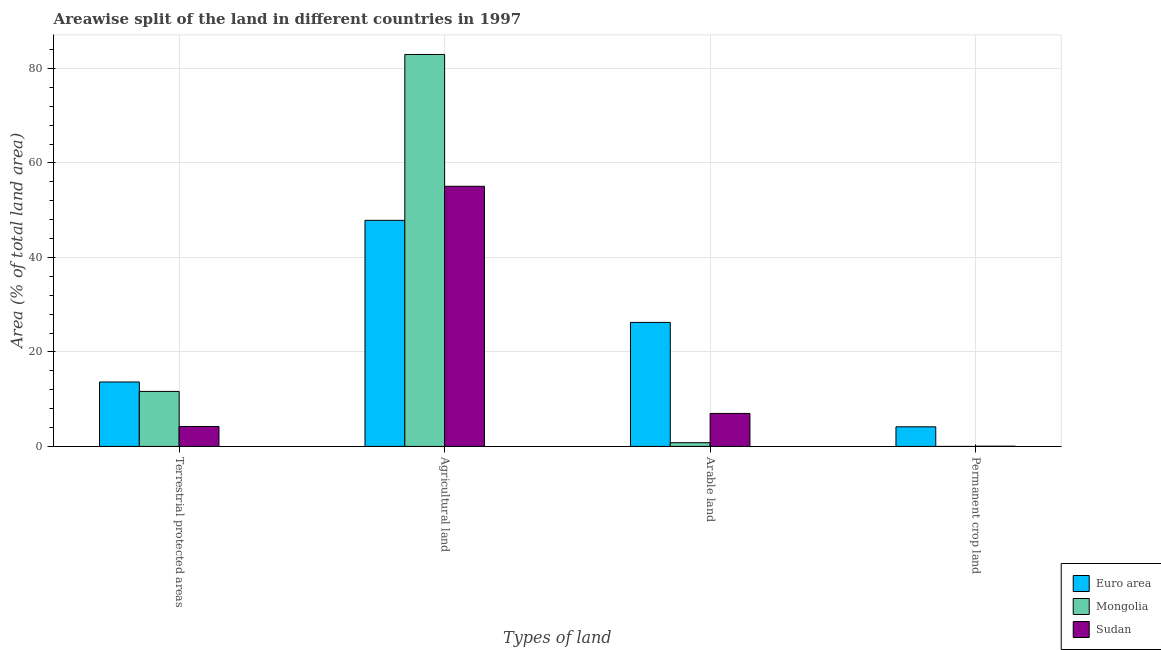How many groups of bars are there?
Make the answer very short. 4. Are the number of bars on each tick of the X-axis equal?
Your answer should be compact. Yes. How many bars are there on the 1st tick from the left?
Give a very brief answer. 3. How many bars are there on the 4th tick from the right?
Your answer should be very brief. 3. What is the label of the 3rd group of bars from the left?
Keep it short and to the point. Arable land. What is the percentage of area under arable land in Sudan?
Provide a short and direct response. 6.99. Across all countries, what is the maximum percentage of area under permanent crop land?
Provide a succinct answer. 4.15. Across all countries, what is the minimum percentage of land under terrestrial protection?
Ensure brevity in your answer.  4.22. In which country was the percentage of land under terrestrial protection minimum?
Provide a succinct answer. Sudan. What is the total percentage of area under permanent crop land in the graph?
Ensure brevity in your answer.  4.2. What is the difference between the percentage of area under agricultural land in Sudan and that in Mongolia?
Provide a succinct answer. -27.9. What is the difference between the percentage of area under agricultural land in Mongolia and the percentage of area under permanent crop land in Sudan?
Ensure brevity in your answer.  82.92. What is the average percentage of area under agricultural land per country?
Make the answer very short. 61.96. What is the difference between the percentage of area under arable land and percentage of area under permanent crop land in Sudan?
Give a very brief answer. 6.94. What is the ratio of the percentage of area under arable land in Sudan to that in Euro area?
Offer a terse response. 0.27. Is the percentage of area under arable land in Sudan less than that in Euro area?
Make the answer very short. Yes. What is the difference between the highest and the second highest percentage of area under permanent crop land?
Ensure brevity in your answer.  4.1. What is the difference between the highest and the lowest percentage of land under terrestrial protection?
Your answer should be compact. 9.42. Is it the case that in every country, the sum of the percentage of area under permanent crop land and percentage of area under agricultural land is greater than the sum of percentage of area under arable land and percentage of land under terrestrial protection?
Provide a succinct answer. No. What does the 3rd bar from the left in Arable land represents?
Offer a terse response. Sudan. What does the 1st bar from the right in Permanent crop land represents?
Offer a terse response. Sudan. How many bars are there?
Provide a succinct answer. 12. Are all the bars in the graph horizontal?
Ensure brevity in your answer.  No. Where does the legend appear in the graph?
Your answer should be compact. Bottom right. What is the title of the graph?
Your answer should be compact. Areawise split of the land in different countries in 1997. What is the label or title of the X-axis?
Provide a succinct answer. Types of land. What is the label or title of the Y-axis?
Your answer should be very brief. Area (% of total land area). What is the Area (% of total land area) of Euro area in Terrestrial protected areas?
Your answer should be very brief. 13.64. What is the Area (% of total land area) in Mongolia in Terrestrial protected areas?
Your answer should be very brief. 11.65. What is the Area (% of total land area) in Sudan in Terrestrial protected areas?
Make the answer very short. 4.22. What is the Area (% of total land area) of Euro area in Agricultural land?
Give a very brief answer. 47.86. What is the Area (% of total land area) in Mongolia in Agricultural land?
Keep it short and to the point. 82.96. What is the Area (% of total land area) of Sudan in Agricultural land?
Your response must be concise. 55.06. What is the Area (% of total land area) of Euro area in Arable land?
Make the answer very short. 26.25. What is the Area (% of total land area) of Mongolia in Arable land?
Your response must be concise. 0.79. What is the Area (% of total land area) of Sudan in Arable land?
Offer a terse response. 6.99. What is the Area (% of total land area) in Euro area in Permanent crop land?
Ensure brevity in your answer.  4.15. What is the Area (% of total land area) in Mongolia in Permanent crop land?
Your answer should be very brief. 0. What is the Area (% of total land area) in Sudan in Permanent crop land?
Give a very brief answer. 0.05. Across all Types of land, what is the maximum Area (% of total land area) of Euro area?
Your answer should be compact. 47.86. Across all Types of land, what is the maximum Area (% of total land area) in Mongolia?
Provide a short and direct response. 82.96. Across all Types of land, what is the maximum Area (% of total land area) in Sudan?
Offer a terse response. 55.06. Across all Types of land, what is the minimum Area (% of total land area) of Euro area?
Provide a short and direct response. 4.15. Across all Types of land, what is the minimum Area (% of total land area) of Mongolia?
Provide a short and direct response. 0. Across all Types of land, what is the minimum Area (% of total land area) in Sudan?
Your answer should be compact. 0.05. What is the total Area (% of total land area) in Euro area in the graph?
Your answer should be compact. 91.9. What is the total Area (% of total land area) of Mongolia in the graph?
Ensure brevity in your answer.  95.4. What is the total Area (% of total land area) of Sudan in the graph?
Offer a very short reply. 66.32. What is the difference between the Area (% of total land area) in Euro area in Terrestrial protected areas and that in Agricultural land?
Provide a succinct answer. -34.22. What is the difference between the Area (% of total land area) in Mongolia in Terrestrial protected areas and that in Agricultural land?
Give a very brief answer. -71.32. What is the difference between the Area (% of total land area) of Sudan in Terrestrial protected areas and that in Agricultural land?
Ensure brevity in your answer.  -50.84. What is the difference between the Area (% of total land area) of Euro area in Terrestrial protected areas and that in Arable land?
Your response must be concise. -12.61. What is the difference between the Area (% of total land area) of Mongolia in Terrestrial protected areas and that in Arable land?
Provide a short and direct response. 10.86. What is the difference between the Area (% of total land area) of Sudan in Terrestrial protected areas and that in Arable land?
Give a very brief answer. -2.76. What is the difference between the Area (% of total land area) in Euro area in Terrestrial protected areas and that in Permanent crop land?
Make the answer very short. 9.49. What is the difference between the Area (% of total land area) in Mongolia in Terrestrial protected areas and that in Permanent crop land?
Your response must be concise. 11.65. What is the difference between the Area (% of total land area) of Sudan in Terrestrial protected areas and that in Permanent crop land?
Offer a very short reply. 4.17. What is the difference between the Area (% of total land area) of Euro area in Agricultural land and that in Arable land?
Provide a short and direct response. 21.61. What is the difference between the Area (% of total land area) in Mongolia in Agricultural land and that in Arable land?
Offer a terse response. 82.18. What is the difference between the Area (% of total land area) in Sudan in Agricultural land and that in Arable land?
Offer a terse response. 48.08. What is the difference between the Area (% of total land area) of Euro area in Agricultural land and that in Permanent crop land?
Provide a succinct answer. 43.71. What is the difference between the Area (% of total land area) in Mongolia in Agricultural land and that in Permanent crop land?
Offer a terse response. 82.96. What is the difference between the Area (% of total land area) in Sudan in Agricultural land and that in Permanent crop land?
Provide a short and direct response. 55.01. What is the difference between the Area (% of total land area) in Euro area in Arable land and that in Permanent crop land?
Provide a short and direct response. 22.1. What is the difference between the Area (% of total land area) in Mongolia in Arable land and that in Permanent crop land?
Your answer should be very brief. 0.79. What is the difference between the Area (% of total land area) in Sudan in Arable land and that in Permanent crop land?
Your answer should be compact. 6.94. What is the difference between the Area (% of total land area) in Euro area in Terrestrial protected areas and the Area (% of total land area) in Mongolia in Agricultural land?
Offer a very short reply. -69.32. What is the difference between the Area (% of total land area) in Euro area in Terrestrial protected areas and the Area (% of total land area) in Sudan in Agricultural land?
Your answer should be compact. -41.42. What is the difference between the Area (% of total land area) in Mongolia in Terrestrial protected areas and the Area (% of total land area) in Sudan in Agricultural land?
Provide a short and direct response. -43.42. What is the difference between the Area (% of total land area) of Euro area in Terrestrial protected areas and the Area (% of total land area) of Mongolia in Arable land?
Offer a terse response. 12.85. What is the difference between the Area (% of total land area) of Euro area in Terrestrial protected areas and the Area (% of total land area) of Sudan in Arable land?
Your response must be concise. 6.65. What is the difference between the Area (% of total land area) of Mongolia in Terrestrial protected areas and the Area (% of total land area) of Sudan in Arable land?
Your response must be concise. 4.66. What is the difference between the Area (% of total land area) in Euro area in Terrestrial protected areas and the Area (% of total land area) in Mongolia in Permanent crop land?
Ensure brevity in your answer.  13.64. What is the difference between the Area (% of total land area) of Euro area in Terrestrial protected areas and the Area (% of total land area) of Sudan in Permanent crop land?
Your answer should be very brief. 13.59. What is the difference between the Area (% of total land area) of Mongolia in Terrestrial protected areas and the Area (% of total land area) of Sudan in Permanent crop land?
Offer a terse response. 11.6. What is the difference between the Area (% of total land area) in Euro area in Agricultural land and the Area (% of total land area) in Mongolia in Arable land?
Your answer should be compact. 47.07. What is the difference between the Area (% of total land area) of Euro area in Agricultural land and the Area (% of total land area) of Sudan in Arable land?
Your answer should be very brief. 40.87. What is the difference between the Area (% of total land area) of Mongolia in Agricultural land and the Area (% of total land area) of Sudan in Arable land?
Provide a succinct answer. 75.98. What is the difference between the Area (% of total land area) in Euro area in Agricultural land and the Area (% of total land area) in Mongolia in Permanent crop land?
Your answer should be very brief. 47.86. What is the difference between the Area (% of total land area) of Euro area in Agricultural land and the Area (% of total land area) of Sudan in Permanent crop land?
Offer a very short reply. 47.81. What is the difference between the Area (% of total land area) in Mongolia in Agricultural land and the Area (% of total land area) in Sudan in Permanent crop land?
Offer a terse response. 82.92. What is the difference between the Area (% of total land area) in Euro area in Arable land and the Area (% of total land area) in Mongolia in Permanent crop land?
Your answer should be very brief. 26.25. What is the difference between the Area (% of total land area) in Euro area in Arable land and the Area (% of total land area) in Sudan in Permanent crop land?
Your answer should be very brief. 26.2. What is the difference between the Area (% of total land area) of Mongolia in Arable land and the Area (% of total land area) of Sudan in Permanent crop land?
Offer a very short reply. 0.74. What is the average Area (% of total land area) in Euro area per Types of land?
Ensure brevity in your answer.  22.98. What is the average Area (% of total land area) in Mongolia per Types of land?
Make the answer very short. 23.85. What is the average Area (% of total land area) of Sudan per Types of land?
Your response must be concise. 16.58. What is the difference between the Area (% of total land area) of Euro area and Area (% of total land area) of Mongolia in Terrestrial protected areas?
Keep it short and to the point. 2. What is the difference between the Area (% of total land area) in Euro area and Area (% of total land area) in Sudan in Terrestrial protected areas?
Give a very brief answer. 9.42. What is the difference between the Area (% of total land area) in Mongolia and Area (% of total land area) in Sudan in Terrestrial protected areas?
Give a very brief answer. 7.42. What is the difference between the Area (% of total land area) of Euro area and Area (% of total land area) of Mongolia in Agricultural land?
Your answer should be compact. -35.11. What is the difference between the Area (% of total land area) of Euro area and Area (% of total land area) of Sudan in Agricultural land?
Your answer should be compact. -7.21. What is the difference between the Area (% of total land area) of Mongolia and Area (% of total land area) of Sudan in Agricultural land?
Make the answer very short. 27.9. What is the difference between the Area (% of total land area) of Euro area and Area (% of total land area) of Mongolia in Arable land?
Your response must be concise. 25.46. What is the difference between the Area (% of total land area) of Euro area and Area (% of total land area) of Sudan in Arable land?
Provide a succinct answer. 19.27. What is the difference between the Area (% of total land area) of Mongolia and Area (% of total land area) of Sudan in Arable land?
Your answer should be compact. -6.2. What is the difference between the Area (% of total land area) of Euro area and Area (% of total land area) of Mongolia in Permanent crop land?
Offer a terse response. 4.15. What is the difference between the Area (% of total land area) in Euro area and Area (% of total land area) in Sudan in Permanent crop land?
Provide a short and direct response. 4.1. What is the difference between the Area (% of total land area) in Mongolia and Area (% of total land area) in Sudan in Permanent crop land?
Your answer should be very brief. -0.05. What is the ratio of the Area (% of total land area) in Euro area in Terrestrial protected areas to that in Agricultural land?
Provide a short and direct response. 0.28. What is the ratio of the Area (% of total land area) in Mongolia in Terrestrial protected areas to that in Agricultural land?
Offer a terse response. 0.14. What is the ratio of the Area (% of total land area) in Sudan in Terrestrial protected areas to that in Agricultural land?
Offer a terse response. 0.08. What is the ratio of the Area (% of total land area) in Euro area in Terrestrial protected areas to that in Arable land?
Offer a terse response. 0.52. What is the ratio of the Area (% of total land area) in Mongolia in Terrestrial protected areas to that in Arable land?
Ensure brevity in your answer.  14.75. What is the ratio of the Area (% of total land area) of Sudan in Terrestrial protected areas to that in Arable land?
Make the answer very short. 0.6. What is the ratio of the Area (% of total land area) of Euro area in Terrestrial protected areas to that in Permanent crop land?
Keep it short and to the point. 3.28. What is the ratio of the Area (% of total land area) of Mongolia in Terrestrial protected areas to that in Permanent crop land?
Your answer should be very brief. 1.81e+04. What is the ratio of the Area (% of total land area) in Sudan in Terrestrial protected areas to that in Permanent crop land?
Make the answer very short. 85.74. What is the ratio of the Area (% of total land area) of Euro area in Agricultural land to that in Arable land?
Your answer should be very brief. 1.82. What is the ratio of the Area (% of total land area) in Mongolia in Agricultural land to that in Arable land?
Make the answer very short. 105.05. What is the ratio of the Area (% of total land area) of Sudan in Agricultural land to that in Arable land?
Offer a terse response. 7.88. What is the ratio of the Area (% of total land area) in Euro area in Agricultural land to that in Permanent crop land?
Provide a short and direct response. 11.52. What is the ratio of the Area (% of total land area) of Mongolia in Agricultural land to that in Permanent crop land?
Provide a succinct answer. 1.29e+05. What is the ratio of the Area (% of total land area) in Sudan in Agricultural land to that in Permanent crop land?
Keep it short and to the point. 1118.22. What is the ratio of the Area (% of total land area) in Euro area in Arable land to that in Permanent crop land?
Your answer should be very brief. 6.32. What is the ratio of the Area (% of total land area) in Mongolia in Arable land to that in Permanent crop land?
Make the answer very short. 1227. What is the ratio of the Area (% of total land area) of Sudan in Arable land to that in Permanent crop land?
Ensure brevity in your answer.  141.88. What is the difference between the highest and the second highest Area (% of total land area) of Euro area?
Provide a succinct answer. 21.61. What is the difference between the highest and the second highest Area (% of total land area) of Mongolia?
Give a very brief answer. 71.32. What is the difference between the highest and the second highest Area (% of total land area) in Sudan?
Make the answer very short. 48.08. What is the difference between the highest and the lowest Area (% of total land area) in Euro area?
Provide a short and direct response. 43.71. What is the difference between the highest and the lowest Area (% of total land area) in Mongolia?
Keep it short and to the point. 82.96. What is the difference between the highest and the lowest Area (% of total land area) in Sudan?
Provide a short and direct response. 55.01. 